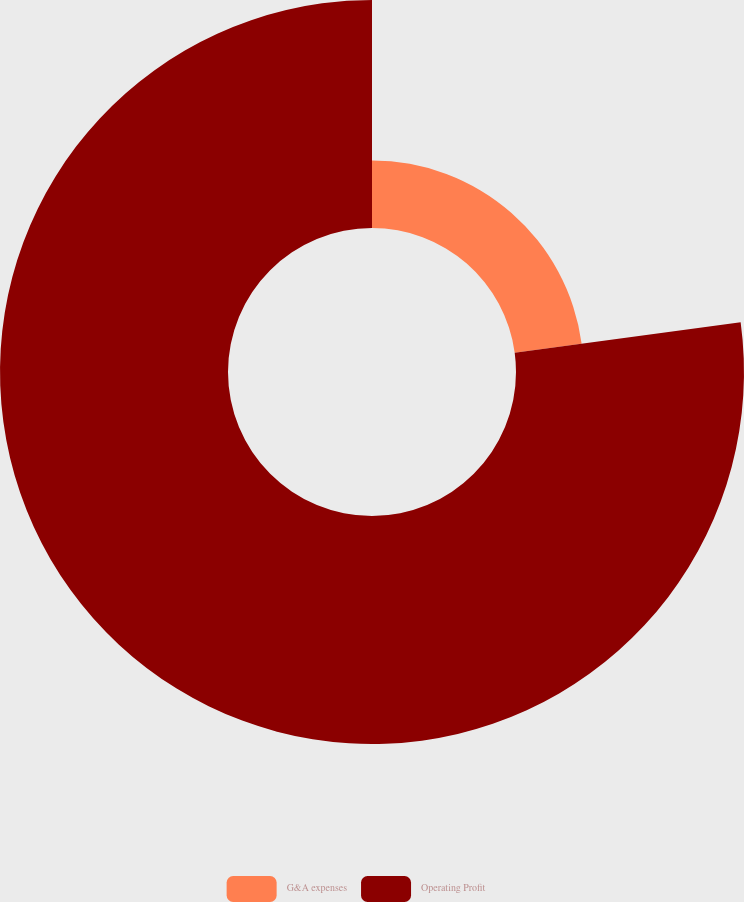Convert chart. <chart><loc_0><loc_0><loc_500><loc_500><pie_chart><fcel>G&A expenses<fcel>Operating Profit<nl><fcel>22.86%<fcel>77.14%<nl></chart> 